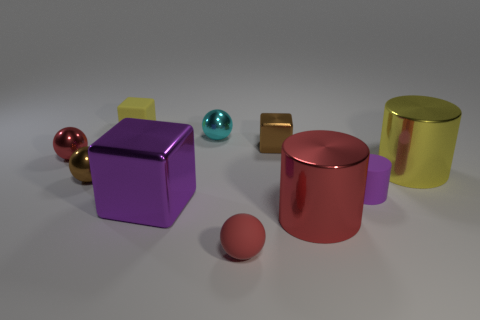Is there any other thing that has the same color as the tiny matte block?
Keep it short and to the point. Yes. What size is the red thing that is behind the metal cylinder in front of the large cylinder that is right of the rubber cylinder?
Ensure brevity in your answer.  Small. The rubber thing that is both on the left side of the purple matte thing and on the right side of the tiny yellow block is what color?
Ensure brevity in your answer.  Red. What size is the brown object to the left of the brown metal block?
Provide a succinct answer. Small. How many purple blocks are the same material as the red cylinder?
Provide a short and direct response. 1. There is a object that is the same color as the small rubber block; what shape is it?
Ensure brevity in your answer.  Cylinder. There is a small rubber object that is on the right side of the red cylinder; is it the same shape as the small cyan thing?
Make the answer very short. No. What is the color of the block that is the same material as the big purple object?
Ensure brevity in your answer.  Brown. There is a red metal thing that is to the left of the tiny brown object behind the yellow metal cylinder; is there a block left of it?
Give a very brief answer. No. What is the shape of the tiny yellow thing?
Offer a very short reply. Cube. 